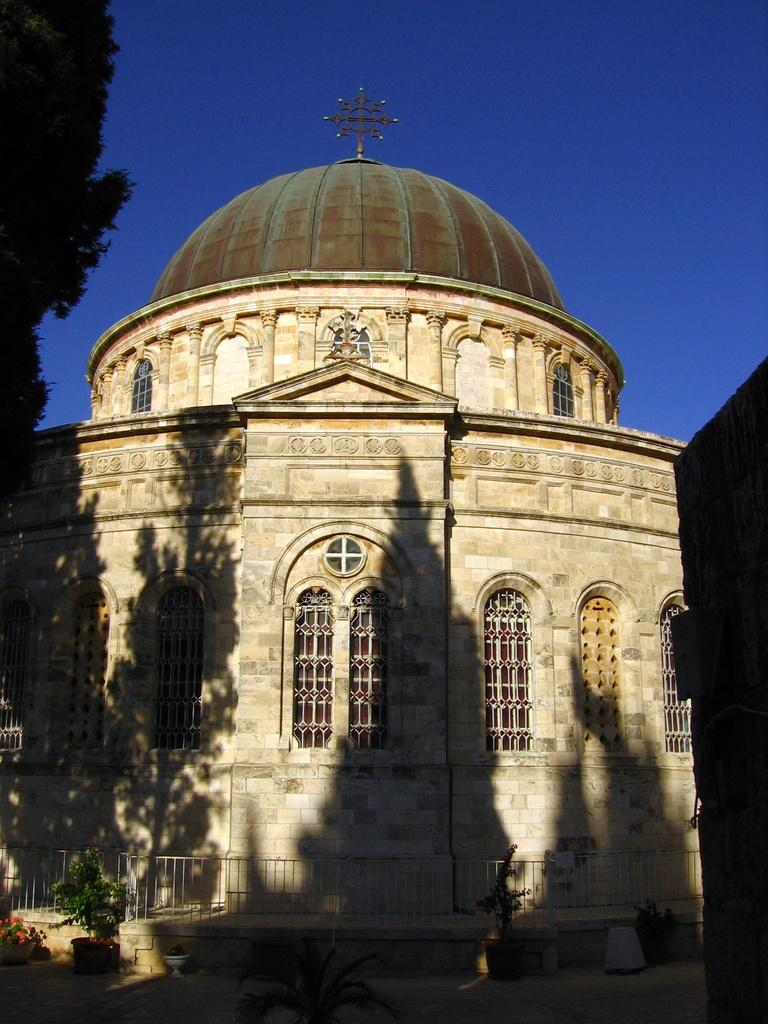What type of structure is visible in the image? There is a building in the image. Can you describe the color of the building? The building is cream-colored. What can be seen in the background of the image? There are trees in the background of the image. What color is the sky in the image? The sky is blue in the image. What type of lipstick is the building wearing in the image? The building is not wearing lipstick, as it is an inanimate object and cannot wear makeup. 